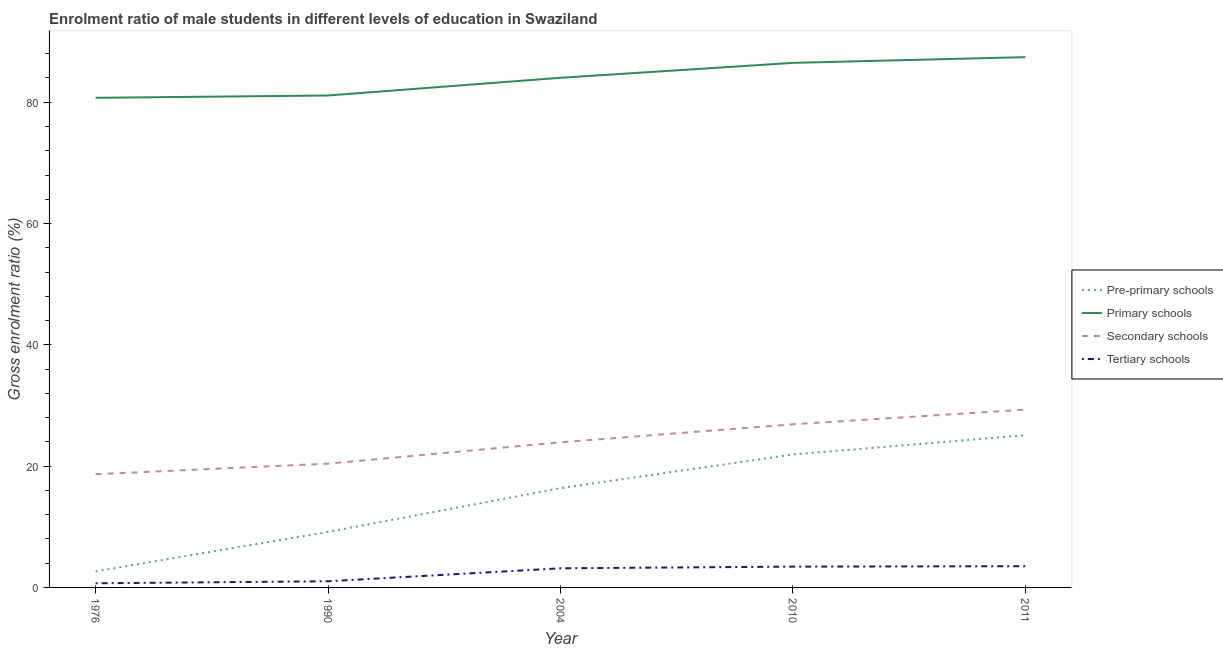How many different coloured lines are there?
Your response must be concise. 4. What is the gross enrolment ratio(female) in pre-primary schools in 1976?
Keep it short and to the point. 2.64. Across all years, what is the maximum gross enrolment ratio(female) in primary schools?
Provide a short and direct response. 87.44. Across all years, what is the minimum gross enrolment ratio(female) in secondary schools?
Your response must be concise. 18.67. In which year was the gross enrolment ratio(female) in pre-primary schools maximum?
Offer a very short reply. 2011. In which year was the gross enrolment ratio(female) in pre-primary schools minimum?
Keep it short and to the point. 1976. What is the total gross enrolment ratio(female) in primary schools in the graph?
Keep it short and to the point. 419.8. What is the difference between the gross enrolment ratio(female) in secondary schools in 1976 and that in 1990?
Provide a short and direct response. -1.74. What is the difference between the gross enrolment ratio(female) in tertiary schools in 2004 and the gross enrolment ratio(female) in primary schools in 1990?
Make the answer very short. -77.96. What is the average gross enrolment ratio(female) in tertiary schools per year?
Your answer should be very brief. 2.36. In the year 1990, what is the difference between the gross enrolment ratio(female) in secondary schools and gross enrolment ratio(female) in tertiary schools?
Keep it short and to the point. 19.39. What is the ratio of the gross enrolment ratio(female) in primary schools in 2004 to that in 2010?
Your response must be concise. 0.97. Is the difference between the gross enrolment ratio(female) in pre-primary schools in 2004 and 2010 greater than the difference between the gross enrolment ratio(female) in tertiary schools in 2004 and 2010?
Offer a terse response. No. What is the difference between the highest and the second highest gross enrolment ratio(female) in pre-primary schools?
Provide a short and direct response. 3.17. What is the difference between the highest and the lowest gross enrolment ratio(female) in pre-primary schools?
Your answer should be compact. 22.46. In how many years, is the gross enrolment ratio(female) in tertiary schools greater than the average gross enrolment ratio(female) in tertiary schools taken over all years?
Ensure brevity in your answer.  3. Is the gross enrolment ratio(female) in primary schools strictly greater than the gross enrolment ratio(female) in pre-primary schools over the years?
Offer a terse response. Yes. Is the gross enrolment ratio(female) in pre-primary schools strictly less than the gross enrolment ratio(female) in secondary schools over the years?
Ensure brevity in your answer.  Yes. How many lines are there?
Provide a succinct answer. 4. How many years are there in the graph?
Your response must be concise. 5. Are the values on the major ticks of Y-axis written in scientific E-notation?
Provide a succinct answer. No. Does the graph contain any zero values?
Offer a terse response. No. Where does the legend appear in the graph?
Provide a succinct answer. Center right. How are the legend labels stacked?
Your answer should be very brief. Vertical. What is the title of the graph?
Provide a succinct answer. Enrolment ratio of male students in different levels of education in Swaziland. Does "Debt policy" appear as one of the legend labels in the graph?
Your answer should be compact. No. What is the label or title of the Y-axis?
Provide a succinct answer. Gross enrolment ratio (%). What is the Gross enrolment ratio (%) in Pre-primary schools in 1976?
Keep it short and to the point. 2.64. What is the Gross enrolment ratio (%) in Primary schools in 1976?
Offer a very short reply. 80.73. What is the Gross enrolment ratio (%) of Secondary schools in 1976?
Your response must be concise. 18.67. What is the Gross enrolment ratio (%) of Tertiary schools in 1976?
Provide a succinct answer. 0.68. What is the Gross enrolment ratio (%) of Pre-primary schools in 1990?
Make the answer very short. 9.16. What is the Gross enrolment ratio (%) of Primary schools in 1990?
Give a very brief answer. 81.11. What is the Gross enrolment ratio (%) in Secondary schools in 1990?
Keep it short and to the point. 20.41. What is the Gross enrolment ratio (%) of Tertiary schools in 1990?
Your answer should be compact. 1.02. What is the Gross enrolment ratio (%) of Pre-primary schools in 2004?
Your response must be concise. 16.37. What is the Gross enrolment ratio (%) of Primary schools in 2004?
Provide a short and direct response. 84.03. What is the Gross enrolment ratio (%) in Secondary schools in 2004?
Make the answer very short. 23.93. What is the Gross enrolment ratio (%) in Tertiary schools in 2004?
Your response must be concise. 3.15. What is the Gross enrolment ratio (%) of Pre-primary schools in 2010?
Your answer should be very brief. 21.93. What is the Gross enrolment ratio (%) of Primary schools in 2010?
Ensure brevity in your answer.  86.49. What is the Gross enrolment ratio (%) of Secondary schools in 2010?
Your response must be concise. 26.9. What is the Gross enrolment ratio (%) of Tertiary schools in 2010?
Your response must be concise. 3.43. What is the Gross enrolment ratio (%) of Pre-primary schools in 2011?
Give a very brief answer. 25.1. What is the Gross enrolment ratio (%) of Primary schools in 2011?
Ensure brevity in your answer.  87.44. What is the Gross enrolment ratio (%) in Secondary schools in 2011?
Your response must be concise. 29.31. What is the Gross enrolment ratio (%) of Tertiary schools in 2011?
Make the answer very short. 3.5. Across all years, what is the maximum Gross enrolment ratio (%) in Pre-primary schools?
Keep it short and to the point. 25.1. Across all years, what is the maximum Gross enrolment ratio (%) in Primary schools?
Keep it short and to the point. 87.44. Across all years, what is the maximum Gross enrolment ratio (%) of Secondary schools?
Provide a succinct answer. 29.31. Across all years, what is the maximum Gross enrolment ratio (%) in Tertiary schools?
Give a very brief answer. 3.5. Across all years, what is the minimum Gross enrolment ratio (%) in Pre-primary schools?
Offer a terse response. 2.64. Across all years, what is the minimum Gross enrolment ratio (%) in Primary schools?
Give a very brief answer. 80.73. Across all years, what is the minimum Gross enrolment ratio (%) in Secondary schools?
Provide a succinct answer. 18.67. Across all years, what is the minimum Gross enrolment ratio (%) in Tertiary schools?
Ensure brevity in your answer.  0.68. What is the total Gross enrolment ratio (%) of Pre-primary schools in the graph?
Provide a succinct answer. 75.2. What is the total Gross enrolment ratio (%) of Primary schools in the graph?
Keep it short and to the point. 419.8. What is the total Gross enrolment ratio (%) of Secondary schools in the graph?
Ensure brevity in your answer.  119.22. What is the total Gross enrolment ratio (%) of Tertiary schools in the graph?
Ensure brevity in your answer.  11.78. What is the difference between the Gross enrolment ratio (%) of Pre-primary schools in 1976 and that in 1990?
Your answer should be very brief. -6.51. What is the difference between the Gross enrolment ratio (%) of Primary schools in 1976 and that in 1990?
Provide a succinct answer. -0.38. What is the difference between the Gross enrolment ratio (%) of Secondary schools in 1976 and that in 1990?
Make the answer very short. -1.74. What is the difference between the Gross enrolment ratio (%) of Tertiary schools in 1976 and that in 1990?
Offer a terse response. -0.33. What is the difference between the Gross enrolment ratio (%) of Pre-primary schools in 1976 and that in 2004?
Your answer should be very brief. -13.73. What is the difference between the Gross enrolment ratio (%) of Primary schools in 1976 and that in 2004?
Give a very brief answer. -3.31. What is the difference between the Gross enrolment ratio (%) in Secondary schools in 1976 and that in 2004?
Your response must be concise. -5.26. What is the difference between the Gross enrolment ratio (%) in Tertiary schools in 1976 and that in 2004?
Ensure brevity in your answer.  -2.47. What is the difference between the Gross enrolment ratio (%) of Pre-primary schools in 1976 and that in 2010?
Provide a short and direct response. -19.29. What is the difference between the Gross enrolment ratio (%) in Primary schools in 1976 and that in 2010?
Make the answer very short. -5.76. What is the difference between the Gross enrolment ratio (%) in Secondary schools in 1976 and that in 2010?
Keep it short and to the point. -8.23. What is the difference between the Gross enrolment ratio (%) in Tertiary schools in 1976 and that in 2010?
Provide a succinct answer. -2.75. What is the difference between the Gross enrolment ratio (%) of Pre-primary schools in 1976 and that in 2011?
Offer a very short reply. -22.46. What is the difference between the Gross enrolment ratio (%) of Primary schools in 1976 and that in 2011?
Your answer should be very brief. -6.71. What is the difference between the Gross enrolment ratio (%) in Secondary schools in 1976 and that in 2011?
Provide a short and direct response. -10.64. What is the difference between the Gross enrolment ratio (%) of Tertiary schools in 1976 and that in 2011?
Make the answer very short. -2.82. What is the difference between the Gross enrolment ratio (%) of Pre-primary schools in 1990 and that in 2004?
Provide a short and direct response. -7.21. What is the difference between the Gross enrolment ratio (%) of Primary schools in 1990 and that in 2004?
Give a very brief answer. -2.92. What is the difference between the Gross enrolment ratio (%) of Secondary schools in 1990 and that in 2004?
Your answer should be compact. -3.52. What is the difference between the Gross enrolment ratio (%) of Tertiary schools in 1990 and that in 2004?
Offer a very short reply. -2.14. What is the difference between the Gross enrolment ratio (%) in Pre-primary schools in 1990 and that in 2010?
Give a very brief answer. -12.77. What is the difference between the Gross enrolment ratio (%) of Primary schools in 1990 and that in 2010?
Your answer should be compact. -5.38. What is the difference between the Gross enrolment ratio (%) of Secondary schools in 1990 and that in 2010?
Your response must be concise. -6.49. What is the difference between the Gross enrolment ratio (%) of Tertiary schools in 1990 and that in 2010?
Give a very brief answer. -2.41. What is the difference between the Gross enrolment ratio (%) in Pre-primary schools in 1990 and that in 2011?
Provide a succinct answer. -15.94. What is the difference between the Gross enrolment ratio (%) of Primary schools in 1990 and that in 2011?
Your answer should be compact. -6.33. What is the difference between the Gross enrolment ratio (%) in Secondary schools in 1990 and that in 2011?
Give a very brief answer. -8.91. What is the difference between the Gross enrolment ratio (%) in Tertiary schools in 1990 and that in 2011?
Ensure brevity in your answer.  -2.48. What is the difference between the Gross enrolment ratio (%) in Pre-primary schools in 2004 and that in 2010?
Make the answer very short. -5.56. What is the difference between the Gross enrolment ratio (%) in Primary schools in 2004 and that in 2010?
Ensure brevity in your answer.  -2.46. What is the difference between the Gross enrolment ratio (%) of Secondary schools in 2004 and that in 2010?
Provide a short and direct response. -2.97. What is the difference between the Gross enrolment ratio (%) in Tertiary schools in 2004 and that in 2010?
Give a very brief answer. -0.28. What is the difference between the Gross enrolment ratio (%) of Pre-primary schools in 2004 and that in 2011?
Provide a short and direct response. -8.73. What is the difference between the Gross enrolment ratio (%) in Primary schools in 2004 and that in 2011?
Your answer should be compact. -3.4. What is the difference between the Gross enrolment ratio (%) of Secondary schools in 2004 and that in 2011?
Your answer should be compact. -5.39. What is the difference between the Gross enrolment ratio (%) in Tertiary schools in 2004 and that in 2011?
Make the answer very short. -0.35. What is the difference between the Gross enrolment ratio (%) of Pre-primary schools in 2010 and that in 2011?
Provide a succinct answer. -3.17. What is the difference between the Gross enrolment ratio (%) in Primary schools in 2010 and that in 2011?
Give a very brief answer. -0.95. What is the difference between the Gross enrolment ratio (%) in Secondary schools in 2010 and that in 2011?
Keep it short and to the point. -2.41. What is the difference between the Gross enrolment ratio (%) of Tertiary schools in 2010 and that in 2011?
Provide a succinct answer. -0.07. What is the difference between the Gross enrolment ratio (%) of Pre-primary schools in 1976 and the Gross enrolment ratio (%) of Primary schools in 1990?
Give a very brief answer. -78.47. What is the difference between the Gross enrolment ratio (%) in Pre-primary schools in 1976 and the Gross enrolment ratio (%) in Secondary schools in 1990?
Provide a short and direct response. -17.76. What is the difference between the Gross enrolment ratio (%) of Pre-primary schools in 1976 and the Gross enrolment ratio (%) of Tertiary schools in 1990?
Provide a short and direct response. 1.63. What is the difference between the Gross enrolment ratio (%) of Primary schools in 1976 and the Gross enrolment ratio (%) of Secondary schools in 1990?
Keep it short and to the point. 60.32. What is the difference between the Gross enrolment ratio (%) in Primary schools in 1976 and the Gross enrolment ratio (%) in Tertiary schools in 1990?
Make the answer very short. 79.71. What is the difference between the Gross enrolment ratio (%) in Secondary schools in 1976 and the Gross enrolment ratio (%) in Tertiary schools in 1990?
Offer a very short reply. 17.65. What is the difference between the Gross enrolment ratio (%) of Pre-primary schools in 1976 and the Gross enrolment ratio (%) of Primary schools in 2004?
Your answer should be very brief. -81.39. What is the difference between the Gross enrolment ratio (%) of Pre-primary schools in 1976 and the Gross enrolment ratio (%) of Secondary schools in 2004?
Ensure brevity in your answer.  -21.29. What is the difference between the Gross enrolment ratio (%) in Pre-primary schools in 1976 and the Gross enrolment ratio (%) in Tertiary schools in 2004?
Your answer should be compact. -0.51. What is the difference between the Gross enrolment ratio (%) of Primary schools in 1976 and the Gross enrolment ratio (%) of Secondary schools in 2004?
Provide a succinct answer. 56.8. What is the difference between the Gross enrolment ratio (%) of Primary schools in 1976 and the Gross enrolment ratio (%) of Tertiary schools in 2004?
Your answer should be very brief. 77.57. What is the difference between the Gross enrolment ratio (%) of Secondary schools in 1976 and the Gross enrolment ratio (%) of Tertiary schools in 2004?
Give a very brief answer. 15.52. What is the difference between the Gross enrolment ratio (%) of Pre-primary schools in 1976 and the Gross enrolment ratio (%) of Primary schools in 2010?
Make the answer very short. -83.85. What is the difference between the Gross enrolment ratio (%) of Pre-primary schools in 1976 and the Gross enrolment ratio (%) of Secondary schools in 2010?
Provide a short and direct response. -24.26. What is the difference between the Gross enrolment ratio (%) in Pre-primary schools in 1976 and the Gross enrolment ratio (%) in Tertiary schools in 2010?
Make the answer very short. -0.79. What is the difference between the Gross enrolment ratio (%) of Primary schools in 1976 and the Gross enrolment ratio (%) of Secondary schools in 2010?
Make the answer very short. 53.83. What is the difference between the Gross enrolment ratio (%) of Primary schools in 1976 and the Gross enrolment ratio (%) of Tertiary schools in 2010?
Ensure brevity in your answer.  77.3. What is the difference between the Gross enrolment ratio (%) of Secondary schools in 1976 and the Gross enrolment ratio (%) of Tertiary schools in 2010?
Offer a very short reply. 15.24. What is the difference between the Gross enrolment ratio (%) in Pre-primary schools in 1976 and the Gross enrolment ratio (%) in Primary schools in 2011?
Offer a very short reply. -84.79. What is the difference between the Gross enrolment ratio (%) in Pre-primary schools in 1976 and the Gross enrolment ratio (%) in Secondary schools in 2011?
Offer a terse response. -26.67. What is the difference between the Gross enrolment ratio (%) of Pre-primary schools in 1976 and the Gross enrolment ratio (%) of Tertiary schools in 2011?
Make the answer very short. -0.86. What is the difference between the Gross enrolment ratio (%) in Primary schools in 1976 and the Gross enrolment ratio (%) in Secondary schools in 2011?
Offer a very short reply. 51.41. What is the difference between the Gross enrolment ratio (%) in Primary schools in 1976 and the Gross enrolment ratio (%) in Tertiary schools in 2011?
Make the answer very short. 77.23. What is the difference between the Gross enrolment ratio (%) in Secondary schools in 1976 and the Gross enrolment ratio (%) in Tertiary schools in 2011?
Ensure brevity in your answer.  15.17. What is the difference between the Gross enrolment ratio (%) in Pre-primary schools in 1990 and the Gross enrolment ratio (%) in Primary schools in 2004?
Make the answer very short. -74.88. What is the difference between the Gross enrolment ratio (%) of Pre-primary schools in 1990 and the Gross enrolment ratio (%) of Secondary schools in 2004?
Provide a short and direct response. -14.77. What is the difference between the Gross enrolment ratio (%) in Pre-primary schools in 1990 and the Gross enrolment ratio (%) in Tertiary schools in 2004?
Offer a very short reply. 6. What is the difference between the Gross enrolment ratio (%) in Primary schools in 1990 and the Gross enrolment ratio (%) in Secondary schools in 2004?
Make the answer very short. 57.18. What is the difference between the Gross enrolment ratio (%) of Primary schools in 1990 and the Gross enrolment ratio (%) of Tertiary schools in 2004?
Ensure brevity in your answer.  77.96. What is the difference between the Gross enrolment ratio (%) of Secondary schools in 1990 and the Gross enrolment ratio (%) of Tertiary schools in 2004?
Offer a terse response. 17.25. What is the difference between the Gross enrolment ratio (%) in Pre-primary schools in 1990 and the Gross enrolment ratio (%) in Primary schools in 2010?
Make the answer very short. -77.33. What is the difference between the Gross enrolment ratio (%) in Pre-primary schools in 1990 and the Gross enrolment ratio (%) in Secondary schools in 2010?
Your response must be concise. -17.74. What is the difference between the Gross enrolment ratio (%) in Pre-primary schools in 1990 and the Gross enrolment ratio (%) in Tertiary schools in 2010?
Your response must be concise. 5.73. What is the difference between the Gross enrolment ratio (%) of Primary schools in 1990 and the Gross enrolment ratio (%) of Secondary schools in 2010?
Your answer should be very brief. 54.21. What is the difference between the Gross enrolment ratio (%) of Primary schools in 1990 and the Gross enrolment ratio (%) of Tertiary schools in 2010?
Provide a succinct answer. 77.68. What is the difference between the Gross enrolment ratio (%) of Secondary schools in 1990 and the Gross enrolment ratio (%) of Tertiary schools in 2010?
Make the answer very short. 16.98. What is the difference between the Gross enrolment ratio (%) in Pre-primary schools in 1990 and the Gross enrolment ratio (%) in Primary schools in 2011?
Offer a terse response. -78.28. What is the difference between the Gross enrolment ratio (%) of Pre-primary schools in 1990 and the Gross enrolment ratio (%) of Secondary schools in 2011?
Your response must be concise. -20.16. What is the difference between the Gross enrolment ratio (%) of Pre-primary schools in 1990 and the Gross enrolment ratio (%) of Tertiary schools in 2011?
Make the answer very short. 5.66. What is the difference between the Gross enrolment ratio (%) in Primary schools in 1990 and the Gross enrolment ratio (%) in Secondary schools in 2011?
Keep it short and to the point. 51.8. What is the difference between the Gross enrolment ratio (%) of Primary schools in 1990 and the Gross enrolment ratio (%) of Tertiary schools in 2011?
Your response must be concise. 77.61. What is the difference between the Gross enrolment ratio (%) of Secondary schools in 1990 and the Gross enrolment ratio (%) of Tertiary schools in 2011?
Your answer should be compact. 16.91. What is the difference between the Gross enrolment ratio (%) in Pre-primary schools in 2004 and the Gross enrolment ratio (%) in Primary schools in 2010?
Your response must be concise. -70.12. What is the difference between the Gross enrolment ratio (%) in Pre-primary schools in 2004 and the Gross enrolment ratio (%) in Secondary schools in 2010?
Provide a short and direct response. -10.53. What is the difference between the Gross enrolment ratio (%) in Pre-primary schools in 2004 and the Gross enrolment ratio (%) in Tertiary schools in 2010?
Offer a very short reply. 12.94. What is the difference between the Gross enrolment ratio (%) of Primary schools in 2004 and the Gross enrolment ratio (%) of Secondary schools in 2010?
Provide a succinct answer. 57.13. What is the difference between the Gross enrolment ratio (%) in Primary schools in 2004 and the Gross enrolment ratio (%) in Tertiary schools in 2010?
Make the answer very short. 80.6. What is the difference between the Gross enrolment ratio (%) of Secondary schools in 2004 and the Gross enrolment ratio (%) of Tertiary schools in 2010?
Offer a terse response. 20.5. What is the difference between the Gross enrolment ratio (%) of Pre-primary schools in 2004 and the Gross enrolment ratio (%) of Primary schools in 2011?
Give a very brief answer. -71.07. What is the difference between the Gross enrolment ratio (%) of Pre-primary schools in 2004 and the Gross enrolment ratio (%) of Secondary schools in 2011?
Make the answer very short. -12.94. What is the difference between the Gross enrolment ratio (%) of Pre-primary schools in 2004 and the Gross enrolment ratio (%) of Tertiary schools in 2011?
Your answer should be compact. 12.87. What is the difference between the Gross enrolment ratio (%) of Primary schools in 2004 and the Gross enrolment ratio (%) of Secondary schools in 2011?
Ensure brevity in your answer.  54.72. What is the difference between the Gross enrolment ratio (%) in Primary schools in 2004 and the Gross enrolment ratio (%) in Tertiary schools in 2011?
Keep it short and to the point. 80.53. What is the difference between the Gross enrolment ratio (%) in Secondary schools in 2004 and the Gross enrolment ratio (%) in Tertiary schools in 2011?
Give a very brief answer. 20.43. What is the difference between the Gross enrolment ratio (%) of Pre-primary schools in 2010 and the Gross enrolment ratio (%) of Primary schools in 2011?
Your answer should be compact. -65.51. What is the difference between the Gross enrolment ratio (%) in Pre-primary schools in 2010 and the Gross enrolment ratio (%) in Secondary schools in 2011?
Keep it short and to the point. -7.38. What is the difference between the Gross enrolment ratio (%) of Pre-primary schools in 2010 and the Gross enrolment ratio (%) of Tertiary schools in 2011?
Give a very brief answer. 18.43. What is the difference between the Gross enrolment ratio (%) of Primary schools in 2010 and the Gross enrolment ratio (%) of Secondary schools in 2011?
Give a very brief answer. 57.18. What is the difference between the Gross enrolment ratio (%) of Primary schools in 2010 and the Gross enrolment ratio (%) of Tertiary schools in 2011?
Offer a very short reply. 82.99. What is the difference between the Gross enrolment ratio (%) in Secondary schools in 2010 and the Gross enrolment ratio (%) in Tertiary schools in 2011?
Offer a terse response. 23.4. What is the average Gross enrolment ratio (%) of Pre-primary schools per year?
Your answer should be very brief. 15.04. What is the average Gross enrolment ratio (%) of Primary schools per year?
Make the answer very short. 83.96. What is the average Gross enrolment ratio (%) in Secondary schools per year?
Your response must be concise. 23.84. What is the average Gross enrolment ratio (%) of Tertiary schools per year?
Offer a terse response. 2.36. In the year 1976, what is the difference between the Gross enrolment ratio (%) in Pre-primary schools and Gross enrolment ratio (%) in Primary schools?
Your answer should be very brief. -78.08. In the year 1976, what is the difference between the Gross enrolment ratio (%) in Pre-primary schools and Gross enrolment ratio (%) in Secondary schools?
Your answer should be compact. -16.03. In the year 1976, what is the difference between the Gross enrolment ratio (%) of Pre-primary schools and Gross enrolment ratio (%) of Tertiary schools?
Give a very brief answer. 1.96. In the year 1976, what is the difference between the Gross enrolment ratio (%) of Primary schools and Gross enrolment ratio (%) of Secondary schools?
Offer a terse response. 62.06. In the year 1976, what is the difference between the Gross enrolment ratio (%) in Primary schools and Gross enrolment ratio (%) in Tertiary schools?
Your response must be concise. 80.04. In the year 1976, what is the difference between the Gross enrolment ratio (%) in Secondary schools and Gross enrolment ratio (%) in Tertiary schools?
Your answer should be very brief. 17.99. In the year 1990, what is the difference between the Gross enrolment ratio (%) of Pre-primary schools and Gross enrolment ratio (%) of Primary schools?
Offer a terse response. -71.95. In the year 1990, what is the difference between the Gross enrolment ratio (%) in Pre-primary schools and Gross enrolment ratio (%) in Secondary schools?
Provide a short and direct response. -11.25. In the year 1990, what is the difference between the Gross enrolment ratio (%) of Pre-primary schools and Gross enrolment ratio (%) of Tertiary schools?
Your answer should be very brief. 8.14. In the year 1990, what is the difference between the Gross enrolment ratio (%) of Primary schools and Gross enrolment ratio (%) of Secondary schools?
Ensure brevity in your answer.  60.7. In the year 1990, what is the difference between the Gross enrolment ratio (%) of Primary schools and Gross enrolment ratio (%) of Tertiary schools?
Your answer should be very brief. 80.09. In the year 1990, what is the difference between the Gross enrolment ratio (%) of Secondary schools and Gross enrolment ratio (%) of Tertiary schools?
Your response must be concise. 19.39. In the year 2004, what is the difference between the Gross enrolment ratio (%) of Pre-primary schools and Gross enrolment ratio (%) of Primary schools?
Offer a terse response. -67.66. In the year 2004, what is the difference between the Gross enrolment ratio (%) in Pre-primary schools and Gross enrolment ratio (%) in Secondary schools?
Your answer should be compact. -7.56. In the year 2004, what is the difference between the Gross enrolment ratio (%) of Pre-primary schools and Gross enrolment ratio (%) of Tertiary schools?
Provide a short and direct response. 13.21. In the year 2004, what is the difference between the Gross enrolment ratio (%) in Primary schools and Gross enrolment ratio (%) in Secondary schools?
Your answer should be compact. 60.1. In the year 2004, what is the difference between the Gross enrolment ratio (%) of Primary schools and Gross enrolment ratio (%) of Tertiary schools?
Offer a very short reply. 80.88. In the year 2004, what is the difference between the Gross enrolment ratio (%) of Secondary schools and Gross enrolment ratio (%) of Tertiary schools?
Provide a short and direct response. 20.77. In the year 2010, what is the difference between the Gross enrolment ratio (%) in Pre-primary schools and Gross enrolment ratio (%) in Primary schools?
Offer a very short reply. -64.56. In the year 2010, what is the difference between the Gross enrolment ratio (%) of Pre-primary schools and Gross enrolment ratio (%) of Secondary schools?
Offer a very short reply. -4.97. In the year 2010, what is the difference between the Gross enrolment ratio (%) of Pre-primary schools and Gross enrolment ratio (%) of Tertiary schools?
Your answer should be compact. 18.5. In the year 2010, what is the difference between the Gross enrolment ratio (%) in Primary schools and Gross enrolment ratio (%) in Secondary schools?
Your answer should be compact. 59.59. In the year 2010, what is the difference between the Gross enrolment ratio (%) of Primary schools and Gross enrolment ratio (%) of Tertiary schools?
Make the answer very short. 83.06. In the year 2010, what is the difference between the Gross enrolment ratio (%) of Secondary schools and Gross enrolment ratio (%) of Tertiary schools?
Offer a very short reply. 23.47. In the year 2011, what is the difference between the Gross enrolment ratio (%) in Pre-primary schools and Gross enrolment ratio (%) in Primary schools?
Ensure brevity in your answer.  -62.34. In the year 2011, what is the difference between the Gross enrolment ratio (%) of Pre-primary schools and Gross enrolment ratio (%) of Secondary schools?
Provide a succinct answer. -4.21. In the year 2011, what is the difference between the Gross enrolment ratio (%) in Pre-primary schools and Gross enrolment ratio (%) in Tertiary schools?
Make the answer very short. 21.6. In the year 2011, what is the difference between the Gross enrolment ratio (%) in Primary schools and Gross enrolment ratio (%) in Secondary schools?
Offer a very short reply. 58.12. In the year 2011, what is the difference between the Gross enrolment ratio (%) in Primary schools and Gross enrolment ratio (%) in Tertiary schools?
Your answer should be compact. 83.94. In the year 2011, what is the difference between the Gross enrolment ratio (%) in Secondary schools and Gross enrolment ratio (%) in Tertiary schools?
Offer a very short reply. 25.81. What is the ratio of the Gross enrolment ratio (%) of Pre-primary schools in 1976 to that in 1990?
Give a very brief answer. 0.29. What is the ratio of the Gross enrolment ratio (%) in Primary schools in 1976 to that in 1990?
Ensure brevity in your answer.  1. What is the ratio of the Gross enrolment ratio (%) in Secondary schools in 1976 to that in 1990?
Provide a succinct answer. 0.91. What is the ratio of the Gross enrolment ratio (%) in Tertiary schools in 1976 to that in 1990?
Provide a succinct answer. 0.67. What is the ratio of the Gross enrolment ratio (%) in Pre-primary schools in 1976 to that in 2004?
Provide a short and direct response. 0.16. What is the ratio of the Gross enrolment ratio (%) in Primary schools in 1976 to that in 2004?
Give a very brief answer. 0.96. What is the ratio of the Gross enrolment ratio (%) in Secondary schools in 1976 to that in 2004?
Offer a very short reply. 0.78. What is the ratio of the Gross enrolment ratio (%) in Tertiary schools in 1976 to that in 2004?
Give a very brief answer. 0.22. What is the ratio of the Gross enrolment ratio (%) of Pre-primary schools in 1976 to that in 2010?
Provide a short and direct response. 0.12. What is the ratio of the Gross enrolment ratio (%) of Primary schools in 1976 to that in 2010?
Make the answer very short. 0.93. What is the ratio of the Gross enrolment ratio (%) in Secondary schools in 1976 to that in 2010?
Ensure brevity in your answer.  0.69. What is the ratio of the Gross enrolment ratio (%) of Tertiary schools in 1976 to that in 2010?
Give a very brief answer. 0.2. What is the ratio of the Gross enrolment ratio (%) of Pre-primary schools in 1976 to that in 2011?
Your answer should be very brief. 0.11. What is the ratio of the Gross enrolment ratio (%) of Primary schools in 1976 to that in 2011?
Give a very brief answer. 0.92. What is the ratio of the Gross enrolment ratio (%) in Secondary schools in 1976 to that in 2011?
Ensure brevity in your answer.  0.64. What is the ratio of the Gross enrolment ratio (%) of Tertiary schools in 1976 to that in 2011?
Your answer should be very brief. 0.2. What is the ratio of the Gross enrolment ratio (%) of Pre-primary schools in 1990 to that in 2004?
Ensure brevity in your answer.  0.56. What is the ratio of the Gross enrolment ratio (%) of Primary schools in 1990 to that in 2004?
Ensure brevity in your answer.  0.97. What is the ratio of the Gross enrolment ratio (%) in Secondary schools in 1990 to that in 2004?
Ensure brevity in your answer.  0.85. What is the ratio of the Gross enrolment ratio (%) in Tertiary schools in 1990 to that in 2004?
Offer a very short reply. 0.32. What is the ratio of the Gross enrolment ratio (%) in Pre-primary schools in 1990 to that in 2010?
Offer a very short reply. 0.42. What is the ratio of the Gross enrolment ratio (%) in Primary schools in 1990 to that in 2010?
Provide a short and direct response. 0.94. What is the ratio of the Gross enrolment ratio (%) of Secondary schools in 1990 to that in 2010?
Your answer should be compact. 0.76. What is the ratio of the Gross enrolment ratio (%) of Tertiary schools in 1990 to that in 2010?
Offer a terse response. 0.3. What is the ratio of the Gross enrolment ratio (%) of Pre-primary schools in 1990 to that in 2011?
Your answer should be compact. 0.36. What is the ratio of the Gross enrolment ratio (%) of Primary schools in 1990 to that in 2011?
Your answer should be very brief. 0.93. What is the ratio of the Gross enrolment ratio (%) of Secondary schools in 1990 to that in 2011?
Provide a succinct answer. 0.7. What is the ratio of the Gross enrolment ratio (%) in Tertiary schools in 1990 to that in 2011?
Offer a very short reply. 0.29. What is the ratio of the Gross enrolment ratio (%) of Pre-primary schools in 2004 to that in 2010?
Keep it short and to the point. 0.75. What is the ratio of the Gross enrolment ratio (%) in Primary schools in 2004 to that in 2010?
Provide a short and direct response. 0.97. What is the ratio of the Gross enrolment ratio (%) of Secondary schools in 2004 to that in 2010?
Your answer should be very brief. 0.89. What is the ratio of the Gross enrolment ratio (%) in Tertiary schools in 2004 to that in 2010?
Keep it short and to the point. 0.92. What is the ratio of the Gross enrolment ratio (%) of Pre-primary schools in 2004 to that in 2011?
Give a very brief answer. 0.65. What is the ratio of the Gross enrolment ratio (%) in Primary schools in 2004 to that in 2011?
Ensure brevity in your answer.  0.96. What is the ratio of the Gross enrolment ratio (%) of Secondary schools in 2004 to that in 2011?
Your response must be concise. 0.82. What is the ratio of the Gross enrolment ratio (%) of Tertiary schools in 2004 to that in 2011?
Your answer should be compact. 0.9. What is the ratio of the Gross enrolment ratio (%) in Pre-primary schools in 2010 to that in 2011?
Ensure brevity in your answer.  0.87. What is the ratio of the Gross enrolment ratio (%) in Secondary schools in 2010 to that in 2011?
Keep it short and to the point. 0.92. What is the ratio of the Gross enrolment ratio (%) in Tertiary schools in 2010 to that in 2011?
Offer a very short reply. 0.98. What is the difference between the highest and the second highest Gross enrolment ratio (%) of Pre-primary schools?
Give a very brief answer. 3.17. What is the difference between the highest and the second highest Gross enrolment ratio (%) of Primary schools?
Offer a very short reply. 0.95. What is the difference between the highest and the second highest Gross enrolment ratio (%) of Secondary schools?
Keep it short and to the point. 2.41. What is the difference between the highest and the second highest Gross enrolment ratio (%) in Tertiary schools?
Provide a short and direct response. 0.07. What is the difference between the highest and the lowest Gross enrolment ratio (%) in Pre-primary schools?
Your response must be concise. 22.46. What is the difference between the highest and the lowest Gross enrolment ratio (%) in Primary schools?
Your answer should be very brief. 6.71. What is the difference between the highest and the lowest Gross enrolment ratio (%) of Secondary schools?
Your answer should be compact. 10.64. What is the difference between the highest and the lowest Gross enrolment ratio (%) of Tertiary schools?
Your response must be concise. 2.82. 